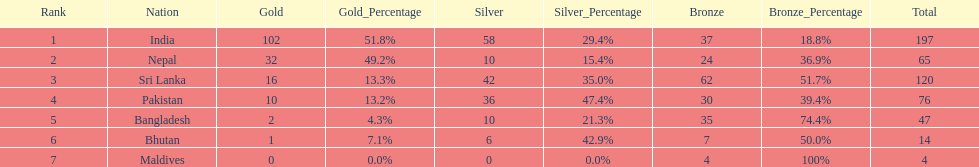What was the only nation to win less than 10 medals total? Maldives. 